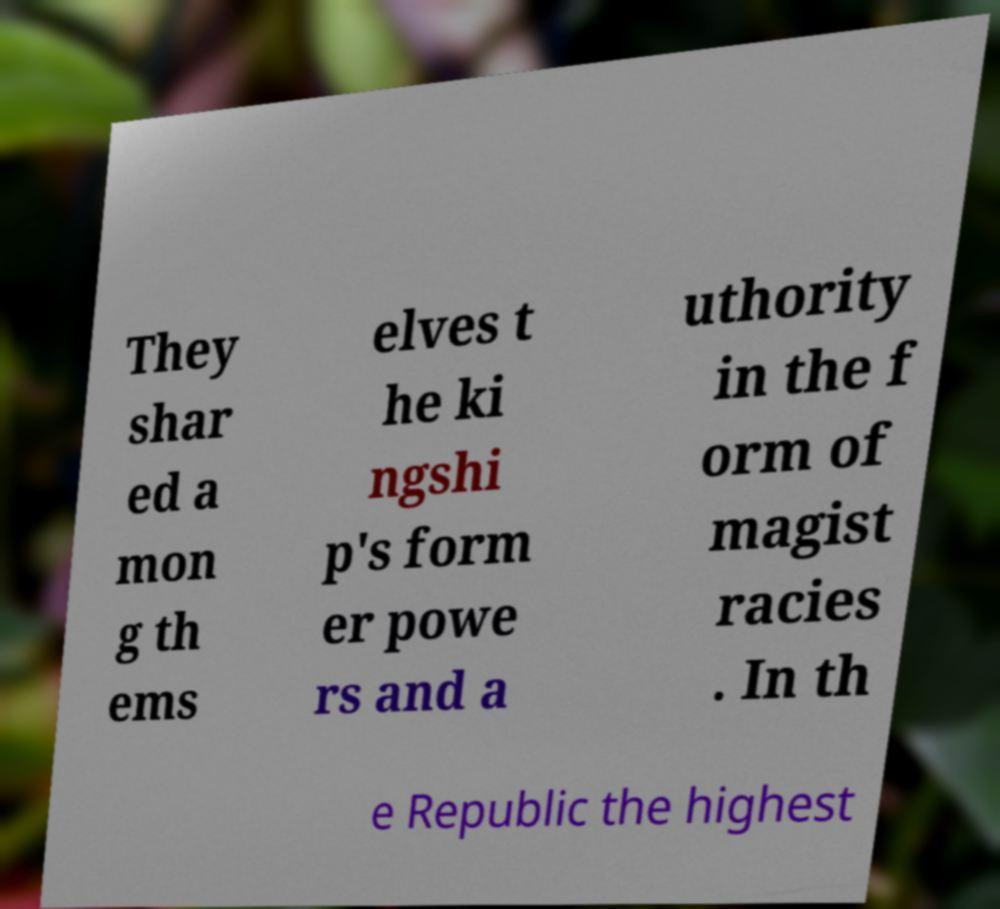Could you extract and type out the text from this image? They shar ed a mon g th ems elves t he ki ngshi p's form er powe rs and a uthority in the f orm of magist racies . In th e Republic the highest 